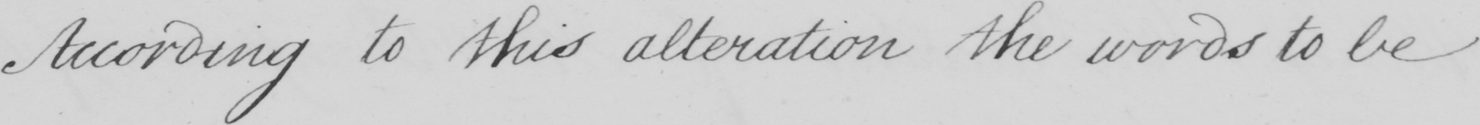Can you tell me what this handwritten text says? According to this alteration the words to be 